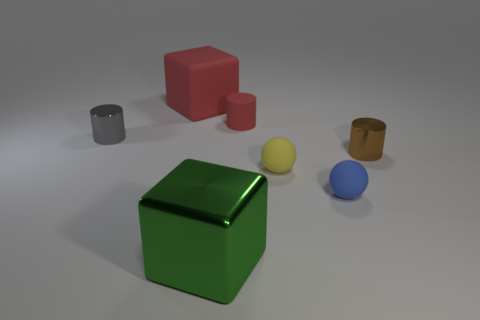Subtract all small gray cylinders. How many cylinders are left? 2 Add 1 big gray matte balls. How many objects exist? 8 Subtract all cyan cylinders. Subtract all yellow spheres. How many cylinders are left? 3 Subtract all spheres. How many objects are left? 5 Add 5 small yellow shiny objects. How many small yellow shiny objects exist? 5 Subtract 0 gray blocks. How many objects are left? 7 Subtract all metal cubes. Subtract all spheres. How many objects are left? 4 Add 5 gray objects. How many gray objects are left? 6 